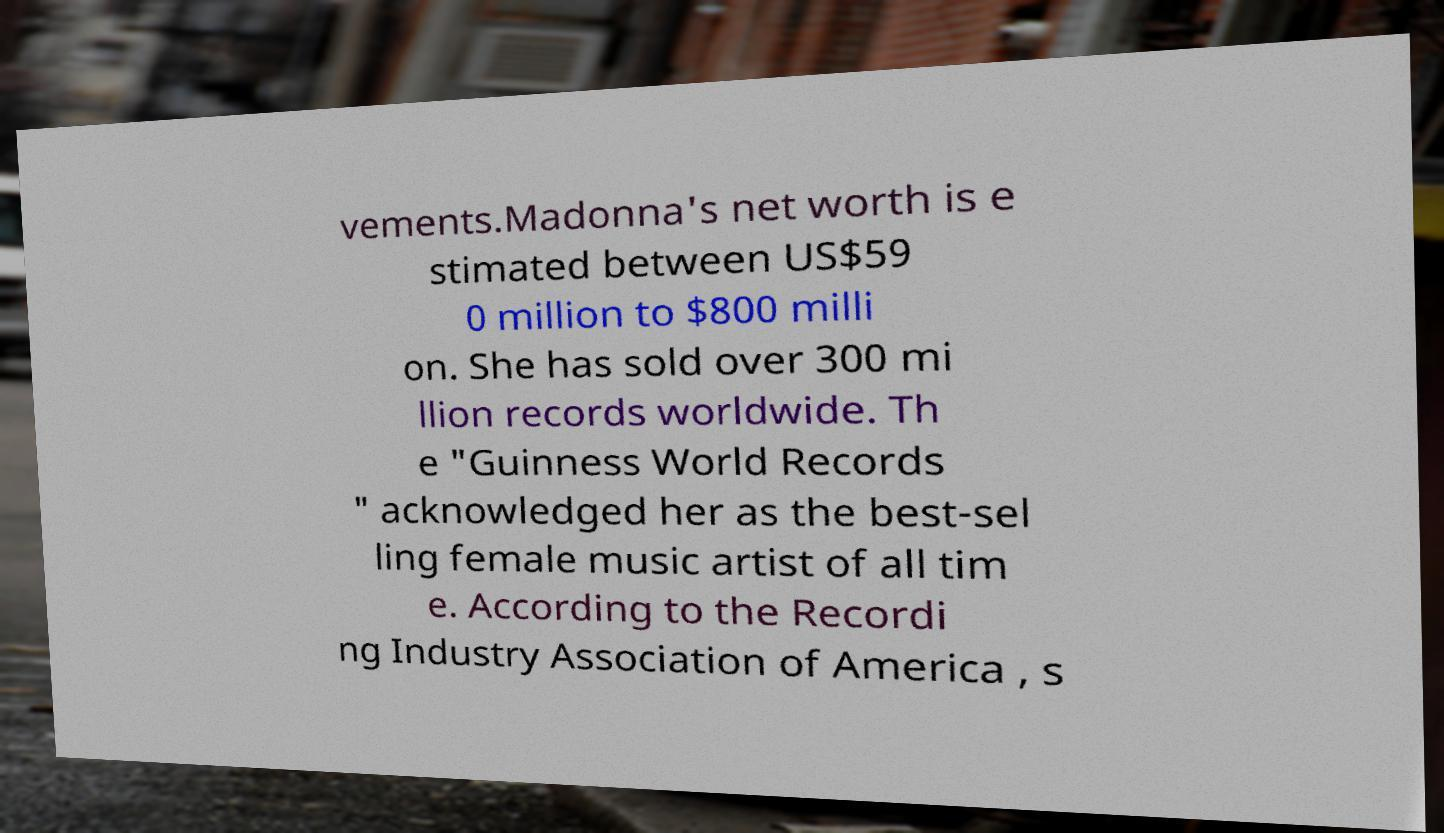For documentation purposes, I need the text within this image transcribed. Could you provide that? vements.Madonna's net worth is e stimated between US$59 0 million to $800 milli on. She has sold over 300 mi llion records worldwide. Th e "Guinness World Records " acknowledged her as the best-sel ling female music artist of all tim e. According to the Recordi ng Industry Association of America , s 